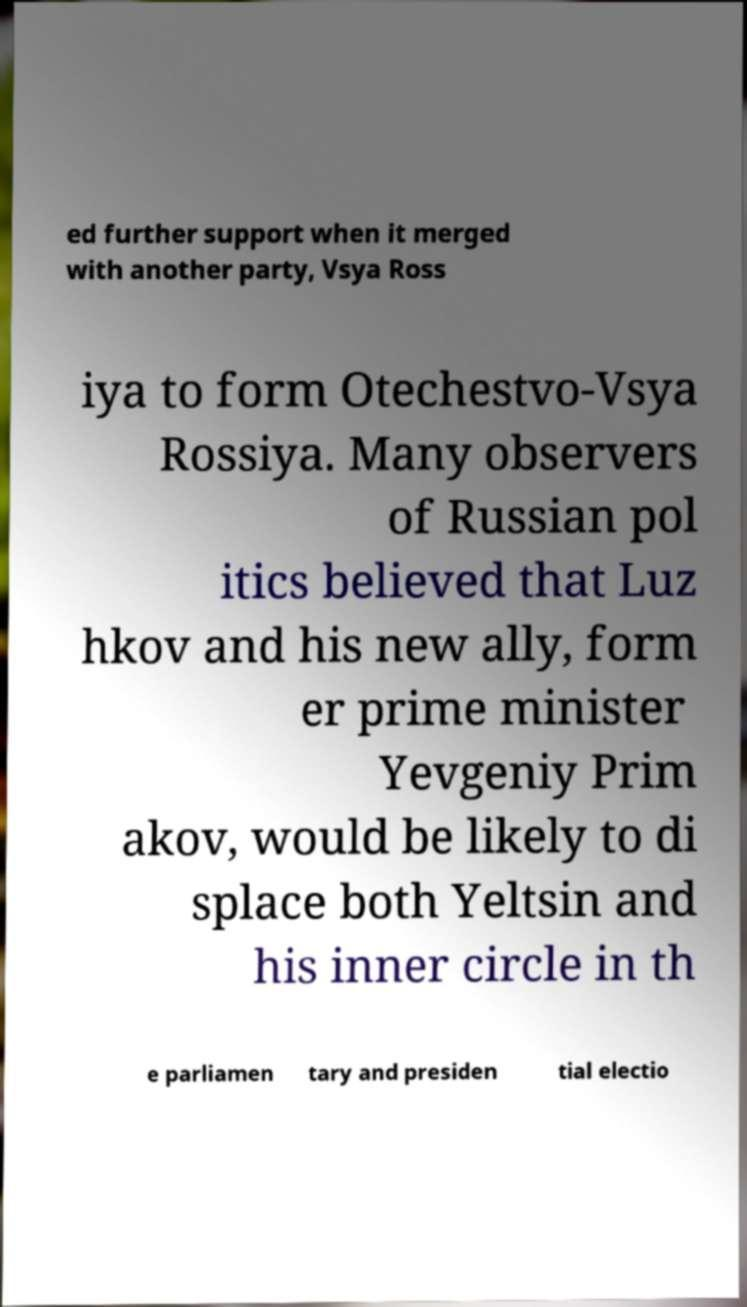Could you extract and type out the text from this image? ed further support when it merged with another party, Vsya Ross iya to form Otechestvo-Vsya Rossiya. Many observers of Russian pol itics believed that Luz hkov and his new ally, form er prime minister Yevgeniy Prim akov, would be likely to di splace both Yeltsin and his inner circle in th e parliamen tary and presiden tial electio 